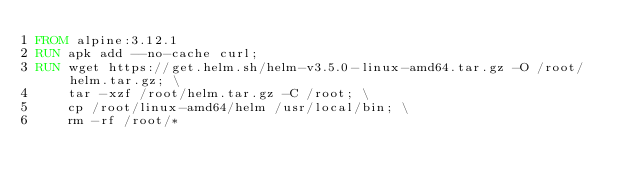<code> <loc_0><loc_0><loc_500><loc_500><_Dockerfile_>FROM alpine:3.12.1
RUN apk add --no-cache curl;
RUN wget https://get.helm.sh/helm-v3.5.0-linux-amd64.tar.gz -O /root/helm.tar.gz; \
    tar -xzf /root/helm.tar.gz -C /root; \
    cp /root/linux-amd64/helm /usr/local/bin; \
    rm -rf /root/*
</code> 